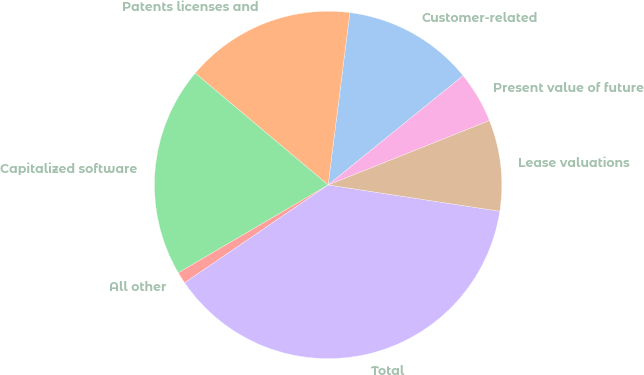Convert chart. <chart><loc_0><loc_0><loc_500><loc_500><pie_chart><fcel>Customer-related<fcel>Patents licenses and<fcel>Capitalized software<fcel>All other<fcel>Total<fcel>Lease valuations<fcel>Present value of future<nl><fcel>12.17%<fcel>15.87%<fcel>19.57%<fcel>1.08%<fcel>38.06%<fcel>8.47%<fcel>4.78%<nl></chart> 